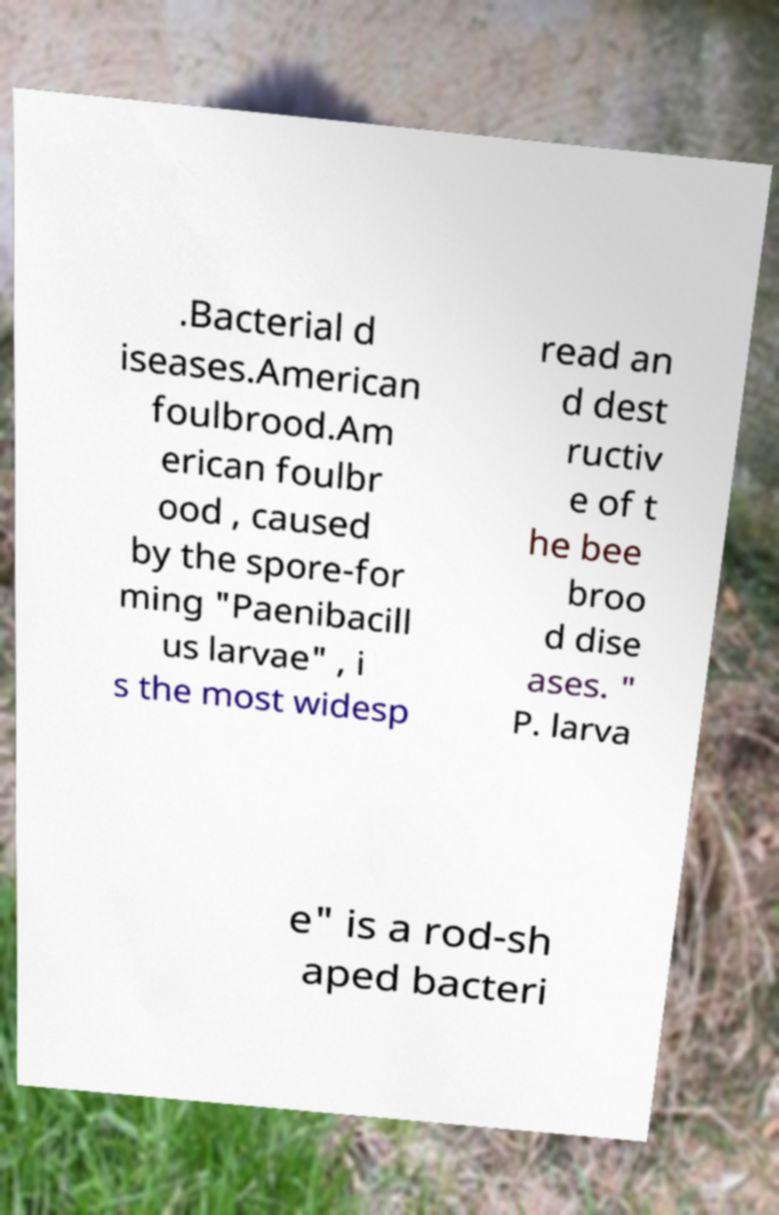There's text embedded in this image that I need extracted. Can you transcribe it verbatim? .Bacterial d iseases.American foulbrood.Am erican foulbr ood , caused by the spore-for ming "Paenibacill us larvae" , i s the most widesp read an d dest ructiv e of t he bee broo d dise ases. " P. larva e" is a rod-sh aped bacteri 